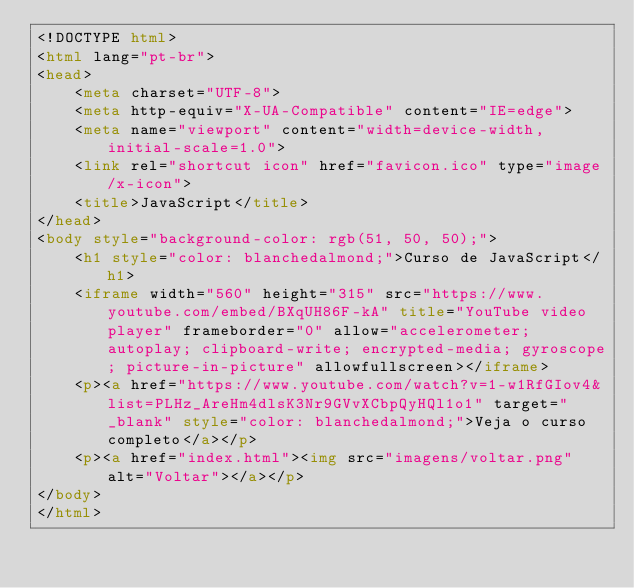Convert code to text. <code><loc_0><loc_0><loc_500><loc_500><_HTML_><!DOCTYPE html>
<html lang="pt-br">
<head>
    <meta charset="UTF-8">
    <meta http-equiv="X-UA-Compatible" content="IE=edge">
    <meta name="viewport" content="width=device-width, initial-scale=1.0">
    <link rel="shortcut icon" href="favicon.ico" type="image/x-icon">
    <title>JavaScript</title>
</head>
<body style="background-color: rgb(51, 50, 50);">
    <h1 style="color: blanchedalmond;">Curso de JavaScript</h1>
    <iframe width="560" height="315" src="https://www.youtube.com/embed/BXqUH86F-kA" title="YouTube video player" frameborder="0" allow="accelerometer; autoplay; clipboard-write; encrypted-media; gyroscope; picture-in-picture" allowfullscreen></iframe>
    <p><a href="https://www.youtube.com/watch?v=1-w1RfGIov4&list=PLHz_AreHm4dlsK3Nr9GVvXCbpQyHQl1o1" target="_blank" style="color: blanchedalmond;">Veja o curso completo</a></p>
    <p><a href="index.html"><img src="imagens/voltar.png" alt="Voltar"></a></p>
</body>
</html></code> 